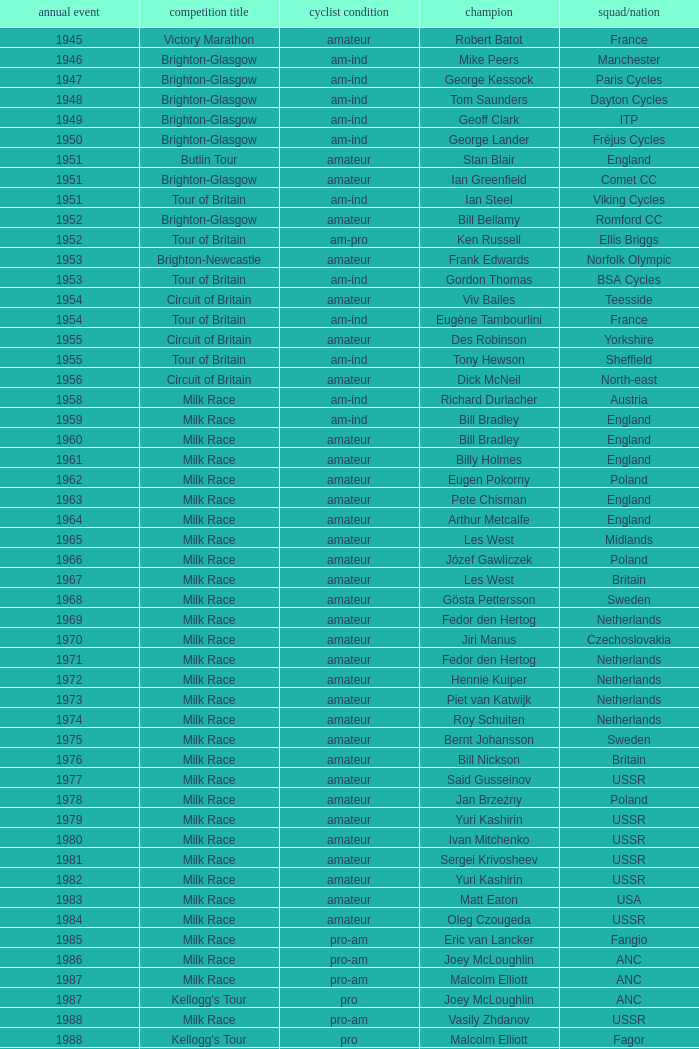What ream played later than 1958 in the kellogg's tour? ANC, Fagor, Z-Peugeot, Weinnmann-SMM, Motorola, Motorola, Motorola, Lampre. 